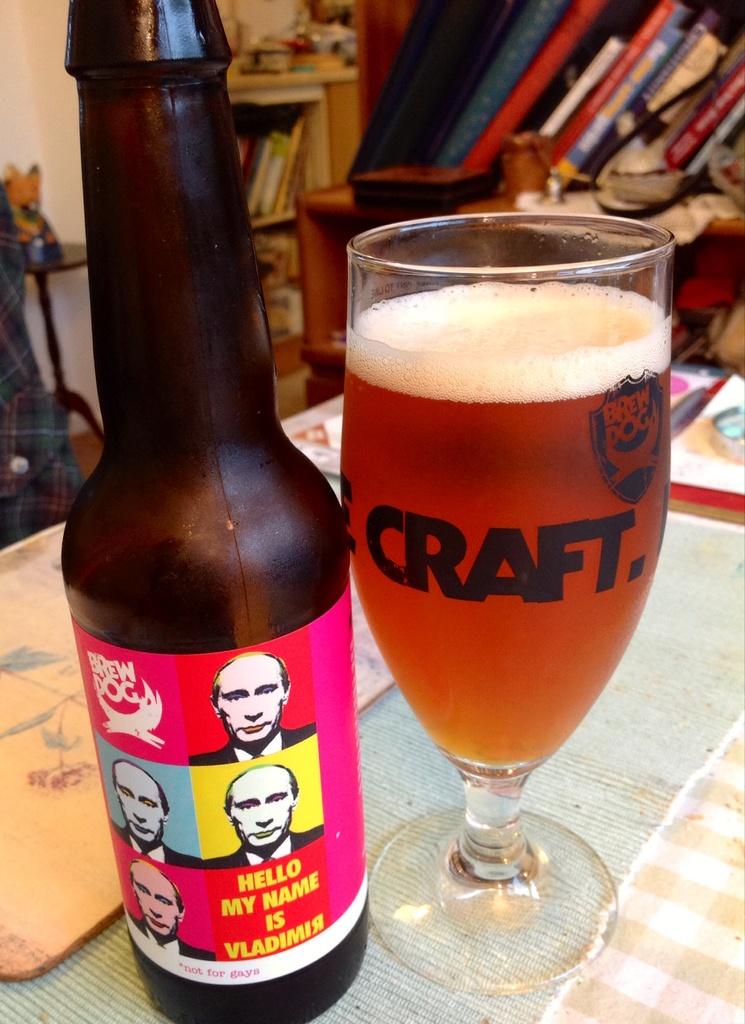What is the company name that made the glass cup?
Your answer should be very brief. Craft. What is the name of the person on the bottle?
Provide a succinct answer. Vladimir. 